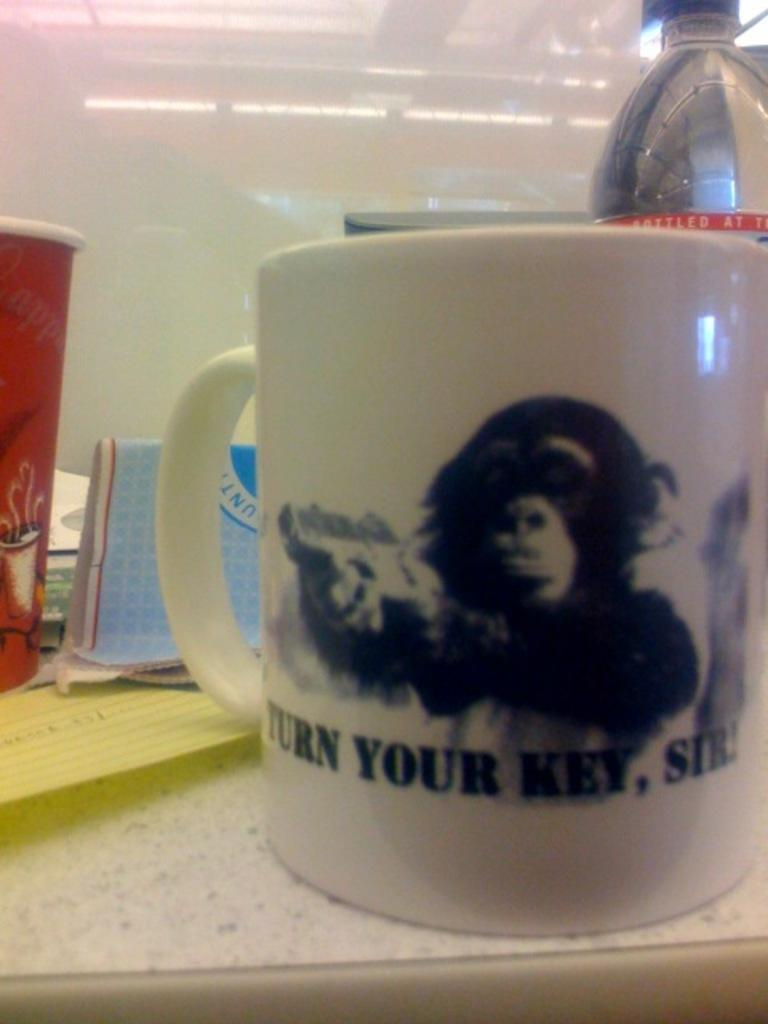<image>
Present a compact description of the photo's key features. A mug with a monkey on it says turn your key, sir. 